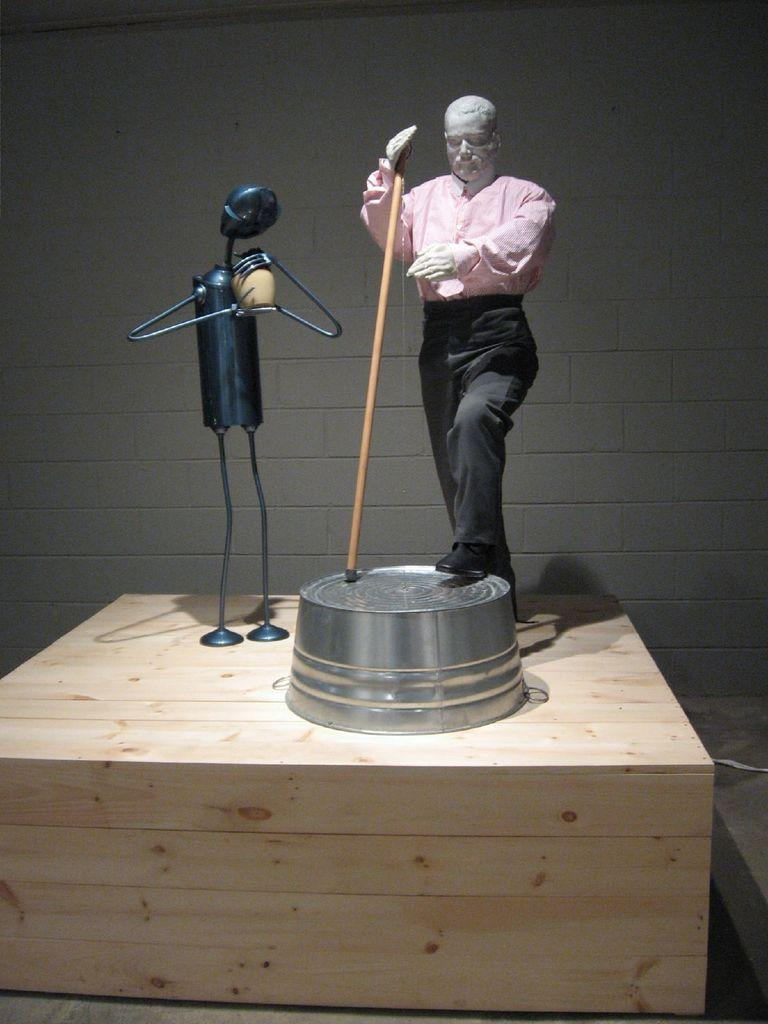What is placed on the wooden block in the image? There are show pieces on a wooden block in the image. What can be seen beneath the wooden block? The surface is visible in the image. What is visible in the background of the image? There is a wall in the background of the image. What type of account is being discussed in the image? There is no mention of an account or any financial discussion in the image. 